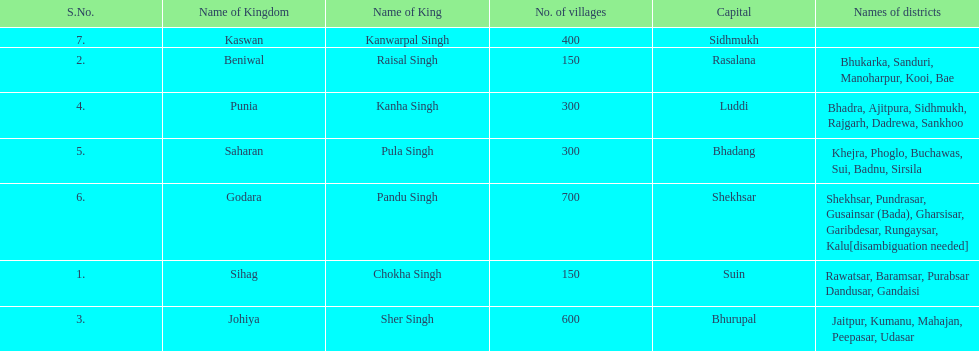What was the total number of districts within the state of godara? 7. 